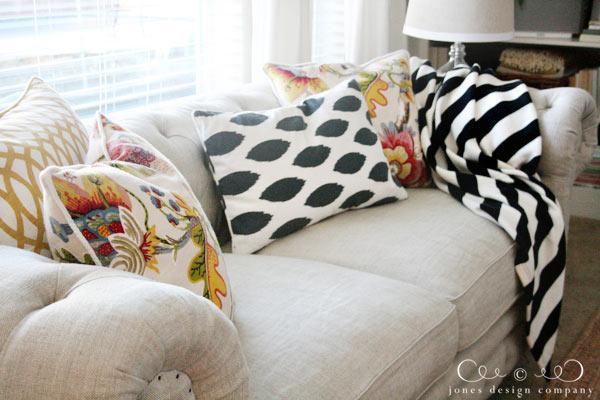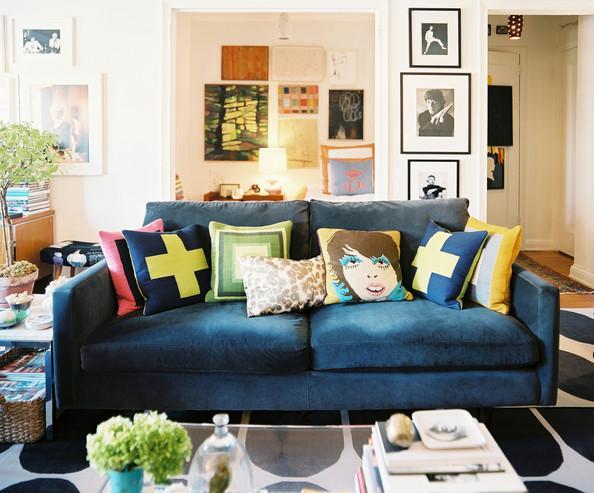The first image is the image on the left, the second image is the image on the right. Analyze the images presented: Is the assertion "There is a blue couch on the right image" valid? Answer yes or no. Yes. The first image is the image on the left, the second image is the image on the right. Assess this claim about the two images: "There is a couch with rolled arms and at least one of its pillows has a bold, geometric black and white design.". Correct or not? Answer yes or no. Yes. 